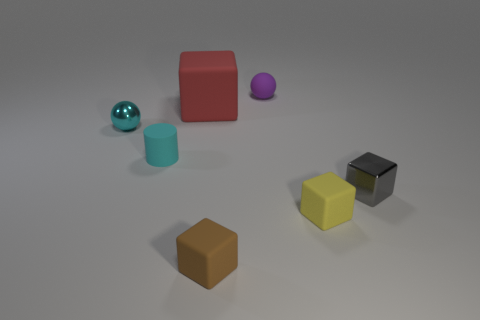Subtract all small blocks. How many blocks are left? 1 Subtract all purple balls. How many balls are left? 1 Subtract all cubes. How many objects are left? 3 Subtract 1 spheres. How many spheres are left? 1 Add 3 small gray metallic objects. How many small gray metallic objects are left? 4 Add 2 metallic balls. How many metallic balls exist? 3 Add 1 small things. How many objects exist? 8 Subtract 1 cyan balls. How many objects are left? 6 Subtract all brown blocks. Subtract all purple spheres. How many blocks are left? 3 Subtract all red balls. How many gray blocks are left? 1 